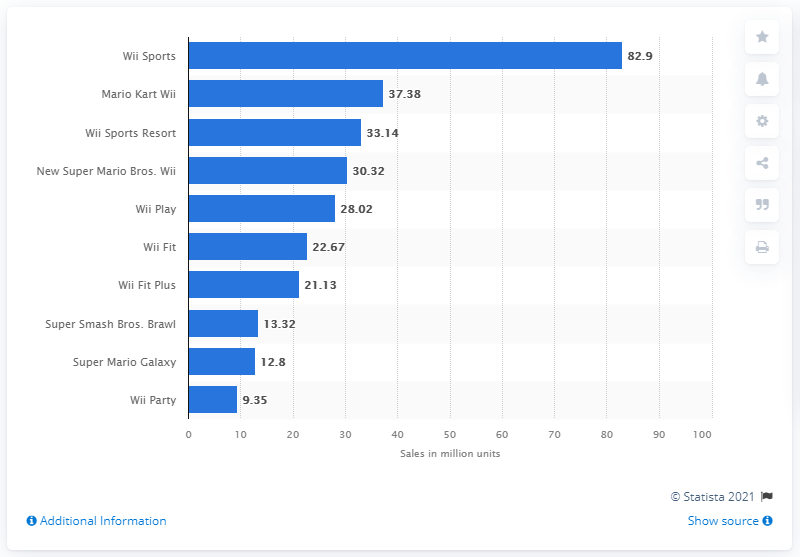Indicate a few pertinent items in this graphic. As of March 2021, the top-selling Nintendo Wii game titles worldwide were Super Mario Galaxy and Wii Party. Super Mario Galaxy was the top-selling game, with over 31 million units sold, while Wii Party sold approximately 21 million units. Mario Kart Wii generated a total of 37.38 units in lifetime sales. As of March 2021, a total of 82.9 Wii Sports units had been sold. As of March 2021, Wii Sports is the top-selling Nintendo Wii game worldwide, with over 82.53 million units sold. 